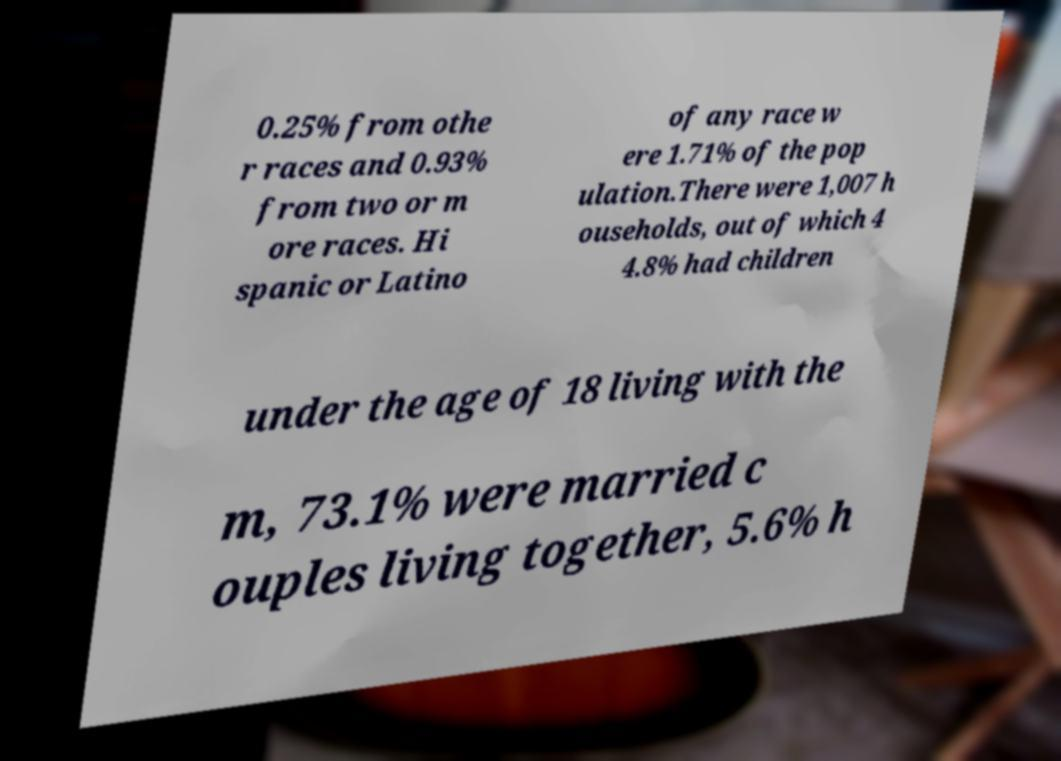Please read and relay the text visible in this image. What does it say? 0.25% from othe r races and 0.93% from two or m ore races. Hi spanic or Latino of any race w ere 1.71% of the pop ulation.There were 1,007 h ouseholds, out of which 4 4.8% had children under the age of 18 living with the m, 73.1% were married c ouples living together, 5.6% h 